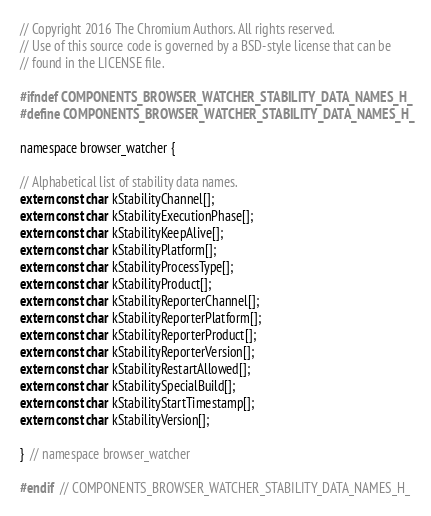<code> <loc_0><loc_0><loc_500><loc_500><_C_>// Copyright 2016 The Chromium Authors. All rights reserved.
// Use of this source code is governed by a BSD-style license that can be
// found in the LICENSE file.

#ifndef COMPONENTS_BROWSER_WATCHER_STABILITY_DATA_NAMES_H_
#define COMPONENTS_BROWSER_WATCHER_STABILITY_DATA_NAMES_H_

namespace browser_watcher {

// Alphabetical list of stability data names.
extern const char kStabilityChannel[];
extern const char kStabilityExecutionPhase[];
extern const char kStabilityKeepAlive[];
extern const char kStabilityPlatform[];
extern const char kStabilityProcessType[];
extern const char kStabilityProduct[];
extern const char kStabilityReporterChannel[];
extern const char kStabilityReporterPlatform[];
extern const char kStabilityReporterProduct[];
extern const char kStabilityReporterVersion[];
extern const char kStabilityRestartAllowed[];
extern const char kStabilitySpecialBuild[];
extern const char kStabilityStartTimestamp[];
extern const char kStabilityVersion[];

}  // namespace browser_watcher

#endif  // COMPONENTS_BROWSER_WATCHER_STABILITY_DATA_NAMES_H_
</code> 